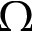<formula> <loc_0><loc_0><loc_500><loc_500>\Omega</formula> 